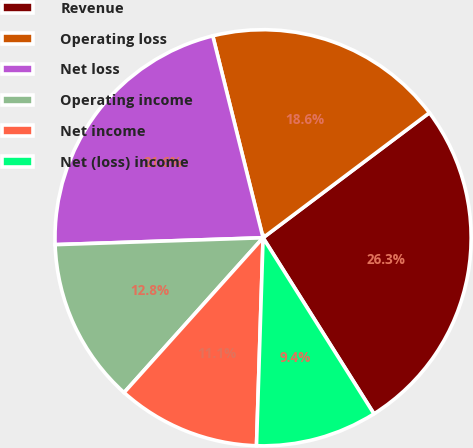Convert chart. <chart><loc_0><loc_0><loc_500><loc_500><pie_chart><fcel>Revenue<fcel>Operating loss<fcel>Net loss<fcel>Operating income<fcel>Net income<fcel>Net (loss) income<nl><fcel>26.31%<fcel>18.63%<fcel>21.64%<fcel>12.83%<fcel>11.14%<fcel>9.45%<nl></chart> 